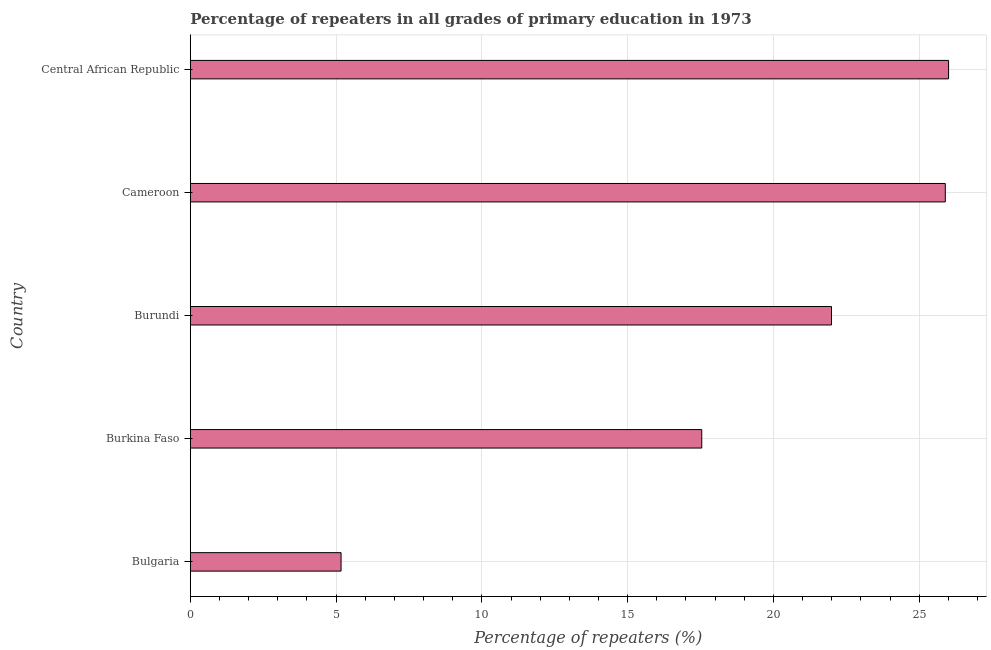What is the title of the graph?
Provide a succinct answer. Percentage of repeaters in all grades of primary education in 1973. What is the label or title of the X-axis?
Keep it short and to the point. Percentage of repeaters (%). What is the percentage of repeaters in primary education in Central African Republic?
Give a very brief answer. 26.01. Across all countries, what is the maximum percentage of repeaters in primary education?
Provide a succinct answer. 26.01. Across all countries, what is the minimum percentage of repeaters in primary education?
Your response must be concise. 5.17. In which country was the percentage of repeaters in primary education maximum?
Your answer should be very brief. Central African Republic. What is the sum of the percentage of repeaters in primary education?
Ensure brevity in your answer.  96.61. What is the difference between the percentage of repeaters in primary education in Burundi and Central African Republic?
Keep it short and to the point. -4.02. What is the average percentage of repeaters in primary education per country?
Offer a very short reply. 19.32. What is the median percentage of repeaters in primary education?
Your answer should be very brief. 21.99. In how many countries, is the percentage of repeaters in primary education greater than 21 %?
Ensure brevity in your answer.  3. What is the ratio of the percentage of repeaters in primary education in Bulgaria to that in Burkina Faso?
Your answer should be compact. 0.29. Is the percentage of repeaters in primary education in Burkina Faso less than that in Central African Republic?
Ensure brevity in your answer.  Yes. Is the difference between the percentage of repeaters in primary education in Cameroon and Central African Republic greater than the difference between any two countries?
Your answer should be compact. No. What is the difference between the highest and the second highest percentage of repeaters in primary education?
Provide a short and direct response. 0.11. Is the sum of the percentage of repeaters in primary education in Burkina Faso and Burundi greater than the maximum percentage of repeaters in primary education across all countries?
Offer a very short reply. Yes. What is the difference between the highest and the lowest percentage of repeaters in primary education?
Keep it short and to the point. 20.84. In how many countries, is the percentage of repeaters in primary education greater than the average percentage of repeaters in primary education taken over all countries?
Provide a succinct answer. 3. Are all the bars in the graph horizontal?
Offer a terse response. Yes. How many countries are there in the graph?
Ensure brevity in your answer.  5. What is the difference between two consecutive major ticks on the X-axis?
Offer a very short reply. 5. Are the values on the major ticks of X-axis written in scientific E-notation?
Provide a short and direct response. No. What is the Percentage of repeaters (%) in Bulgaria?
Offer a very short reply. 5.17. What is the Percentage of repeaters (%) in Burkina Faso?
Provide a short and direct response. 17.54. What is the Percentage of repeaters (%) of Burundi?
Provide a short and direct response. 21.99. What is the Percentage of repeaters (%) of Cameroon?
Offer a very short reply. 25.9. What is the Percentage of repeaters (%) of Central African Republic?
Keep it short and to the point. 26.01. What is the difference between the Percentage of repeaters (%) in Bulgaria and Burkina Faso?
Keep it short and to the point. -12.37. What is the difference between the Percentage of repeaters (%) in Bulgaria and Burundi?
Offer a terse response. -16.82. What is the difference between the Percentage of repeaters (%) in Bulgaria and Cameroon?
Keep it short and to the point. -20.72. What is the difference between the Percentage of repeaters (%) in Bulgaria and Central African Republic?
Ensure brevity in your answer.  -20.84. What is the difference between the Percentage of repeaters (%) in Burkina Faso and Burundi?
Make the answer very short. -4.45. What is the difference between the Percentage of repeaters (%) in Burkina Faso and Cameroon?
Make the answer very short. -8.35. What is the difference between the Percentage of repeaters (%) in Burkina Faso and Central African Republic?
Ensure brevity in your answer.  -8.47. What is the difference between the Percentage of repeaters (%) in Burundi and Cameroon?
Your answer should be compact. -3.9. What is the difference between the Percentage of repeaters (%) in Burundi and Central African Republic?
Give a very brief answer. -4.02. What is the difference between the Percentage of repeaters (%) in Cameroon and Central African Republic?
Offer a terse response. -0.11. What is the ratio of the Percentage of repeaters (%) in Bulgaria to that in Burkina Faso?
Your response must be concise. 0.29. What is the ratio of the Percentage of repeaters (%) in Bulgaria to that in Burundi?
Make the answer very short. 0.23. What is the ratio of the Percentage of repeaters (%) in Bulgaria to that in Central African Republic?
Ensure brevity in your answer.  0.2. What is the ratio of the Percentage of repeaters (%) in Burkina Faso to that in Burundi?
Keep it short and to the point. 0.8. What is the ratio of the Percentage of repeaters (%) in Burkina Faso to that in Cameroon?
Your answer should be compact. 0.68. What is the ratio of the Percentage of repeaters (%) in Burkina Faso to that in Central African Republic?
Your answer should be compact. 0.67. What is the ratio of the Percentage of repeaters (%) in Burundi to that in Cameroon?
Your response must be concise. 0.85. What is the ratio of the Percentage of repeaters (%) in Burundi to that in Central African Republic?
Give a very brief answer. 0.85. What is the ratio of the Percentage of repeaters (%) in Cameroon to that in Central African Republic?
Offer a terse response. 1. 